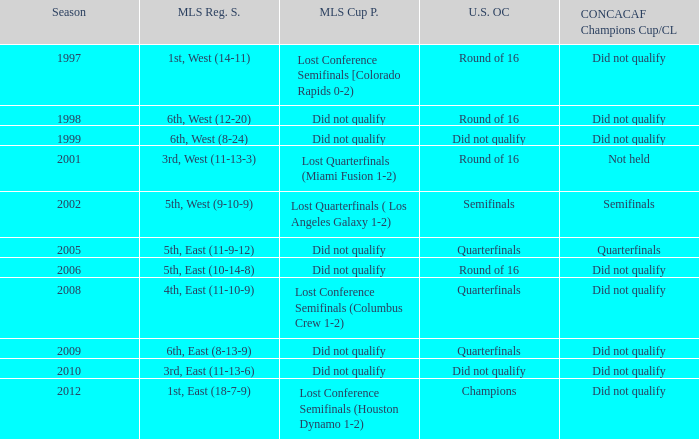When was the first season? 1997.0. 